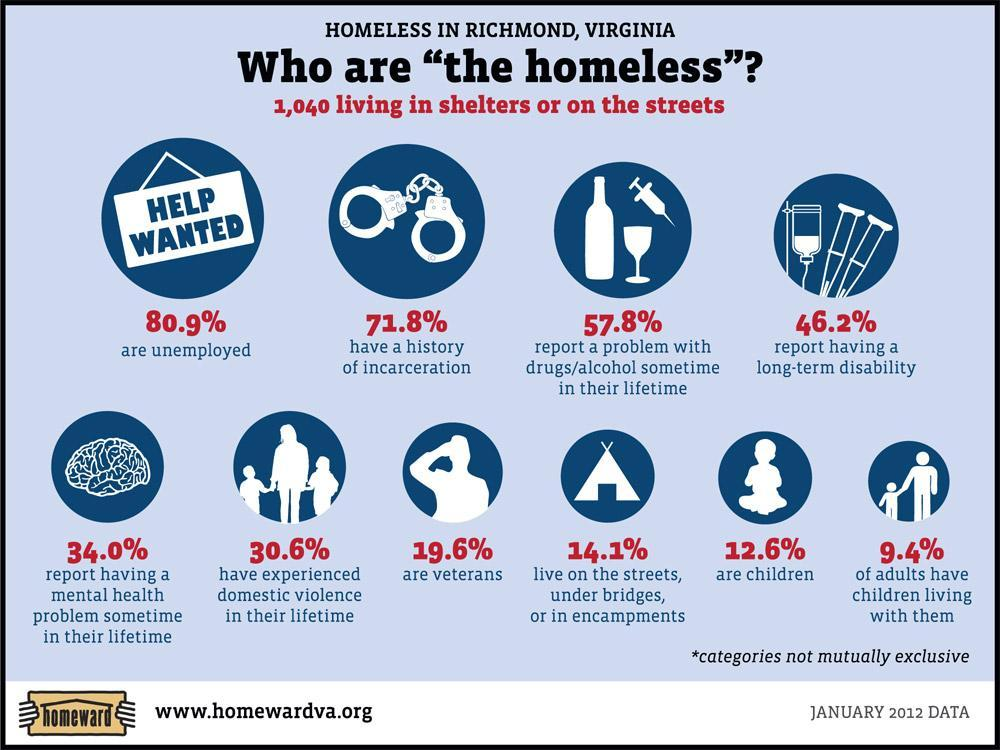What percent of homeless people do not have a long term disability?
Answer the question with a short phrase. 53.8% 